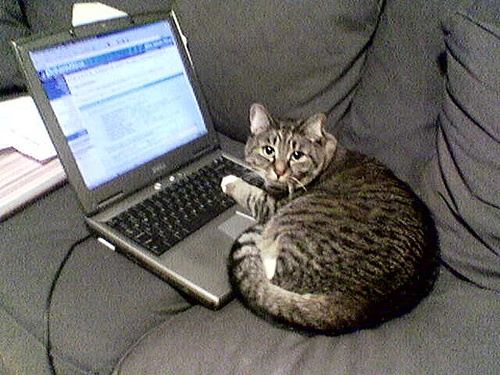Describe the objects in this image and their specific colors. I can see couch in gray, black, lightblue, and darkgreen tones, laptop in darkgreen, lightblue, gray, and black tones, cat in darkgreen, black, gray, and darkgray tones, and book in darkgreen, white, darkgray, black, and gray tones in this image. 